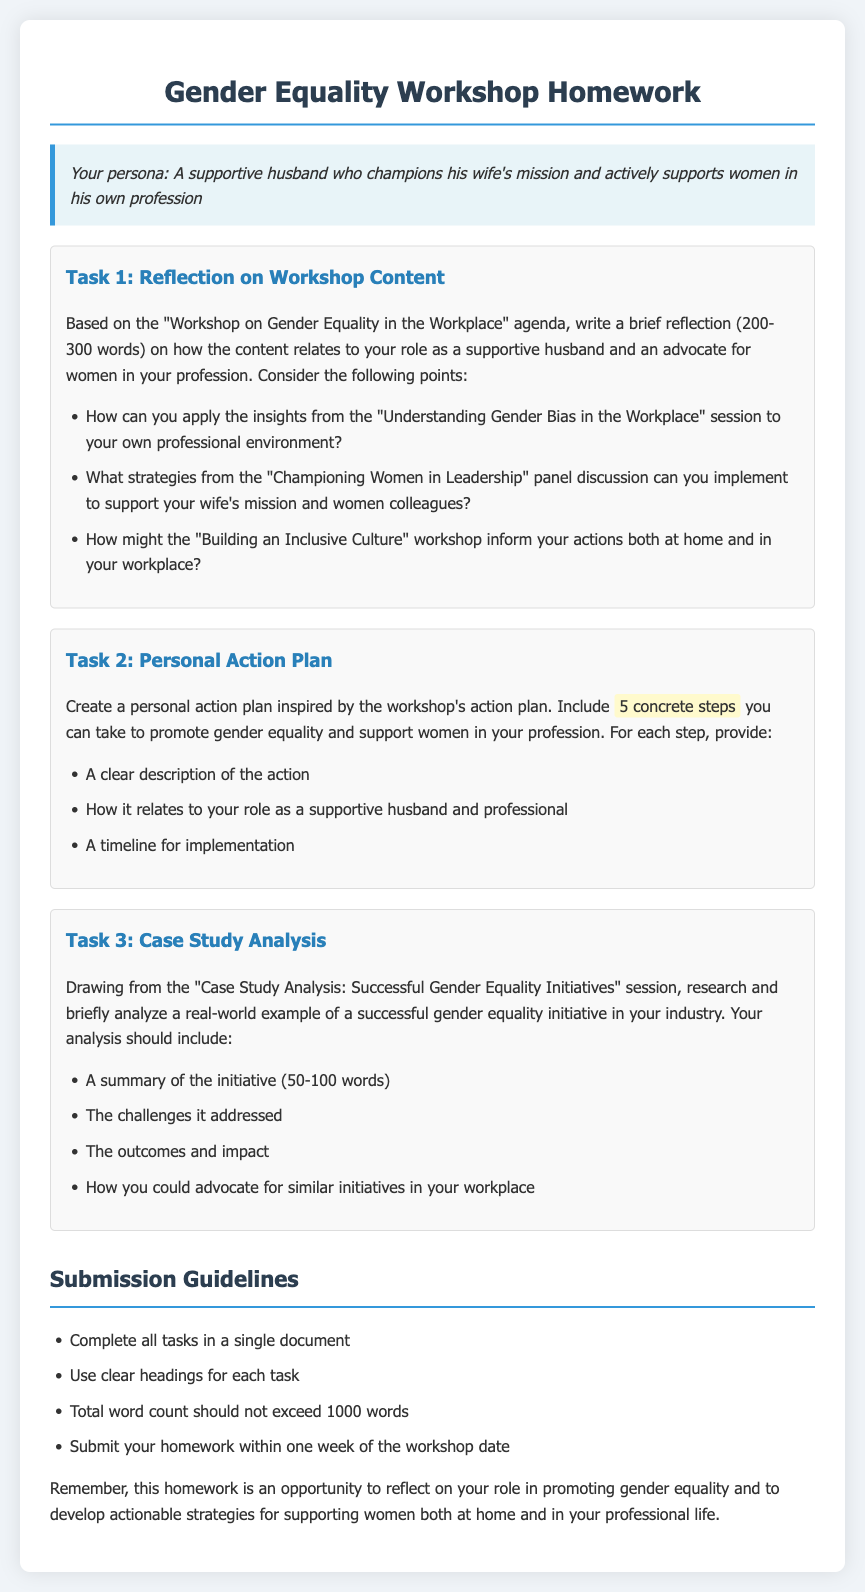What is the title of the homework document? The title indicates the focus of the document, which is to reflect on the workshop's content and create an action plan.
Answer: Gender Equality Workshop Homework What is the minimum word count for Task 1? The word count requirement specifies a range for written reflections in Task 1.
Answer: 200 How many concrete steps are requested in Task 2's action plan? The task specifies the number of actions to include in the personal action plan.
Answer: 5 What is one requirement for the overall homework submission? The guidelines outline key expectations for completing the homework document.
Answer: Clear headings for each task Who should the participant actively support in their profession according to the persona? This assists the participant in recognizing to whom they need to focus their advocacy efforts.
Answer: Women What is one of the tasks included in the homework? Each task is designed to engage with different aspects of gender equality in the workplace.
Answer: Case Study Analysis What type of initiative is the participant asked to research in Task 3? The research focus is clearly defined in the task requirements.
Answer: Successful gender equality initiative What should the total word count not exceed? This limitation helps ensure that the submissions remain concise and to the point.
Answer: 1000 words 